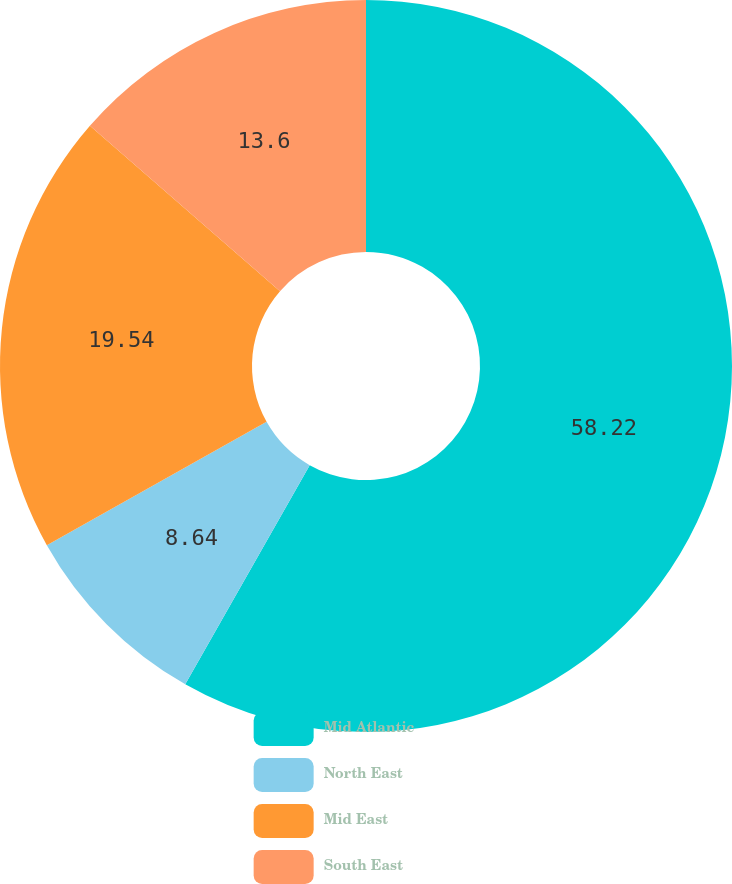Convert chart to OTSL. <chart><loc_0><loc_0><loc_500><loc_500><pie_chart><fcel>Mid Atlantic<fcel>North East<fcel>Mid East<fcel>South East<nl><fcel>58.22%<fcel>8.64%<fcel>19.54%<fcel>13.6%<nl></chart> 